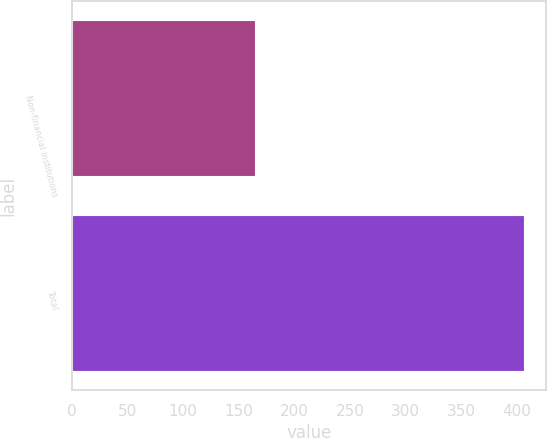Convert chart. <chart><loc_0><loc_0><loc_500><loc_500><bar_chart><fcel>Non-financial institutions<fcel>Total<nl><fcel>164.9<fcel>406.4<nl></chart> 